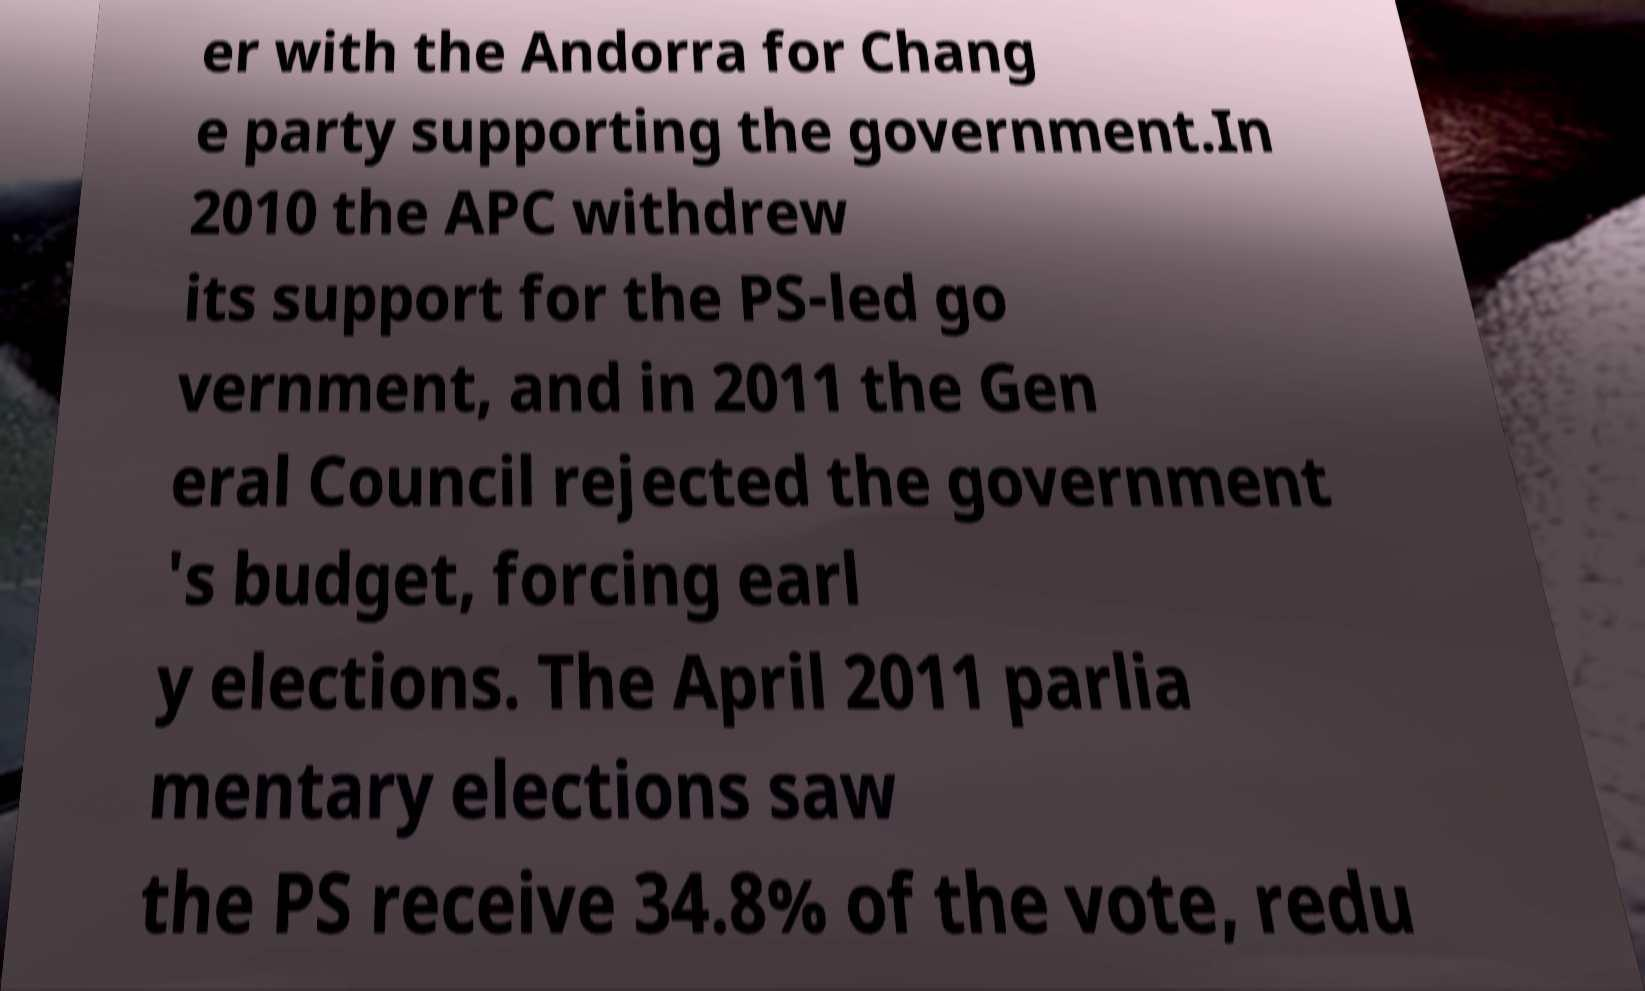Please identify and transcribe the text found in this image. er with the Andorra for Chang e party supporting the government.In 2010 the APC withdrew its support for the PS-led go vernment, and in 2011 the Gen eral Council rejected the government 's budget, forcing earl y elections. The April 2011 parlia mentary elections saw the PS receive 34.8% of the vote, redu 